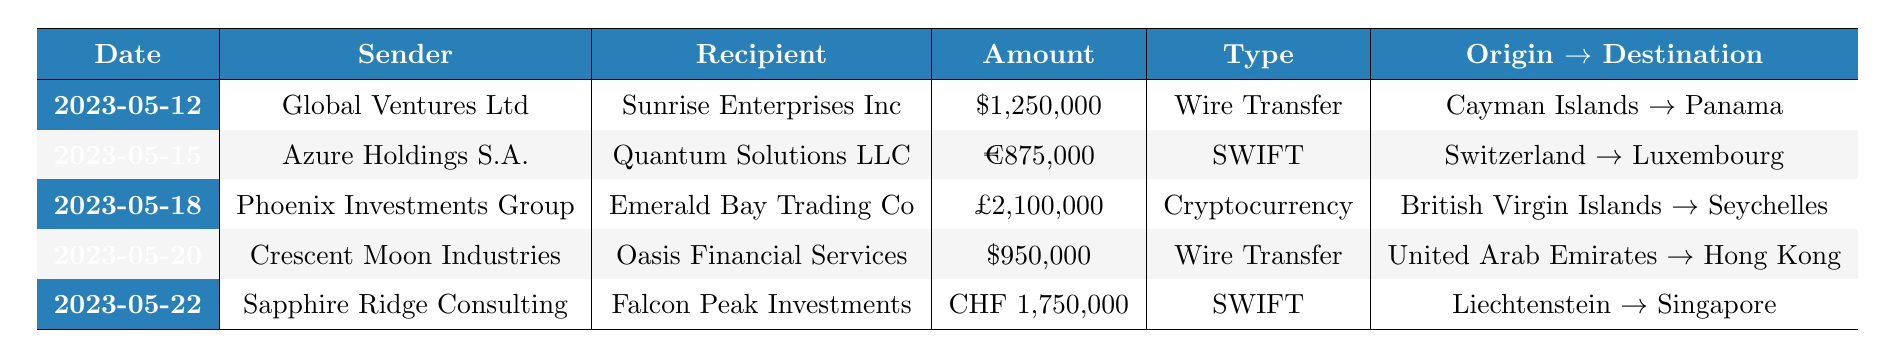What is the total amount of all financial transactions listed in the table? To find the total amount, we need to add together all the transaction amounts: 1,250,000 USD + 875,000 EUR + 2,100,000 GBP + 950,000 USD + 1,750,000 CHF. Each amount is in a different currency, but the question does not require conversion—just a sum of presented values. Therefore, the total amount is the sum of these values as 1,250,000 + 875,000 + 2,100,000 + 950,000 + 1,750,000. The final total is 7,925,000 (not considered in a single currency).
Answer: 7,925,000 Which sender initiated the largest transaction? Looking through the transaction amounts, the largest value is 2,100,000 GBP, which was sent by Phoenix Investments Group. We check each transaction amount against others to confirm this. The maximum amount clearly stands out from the rest.
Answer: Phoenix Investments Group Was there any transaction involving the United States? Examining the table, we see that there are transactions associated with currencies from USD and also a sender (Crescent Moon Industries) and recipient (Oasis Financial Services) linked to the United Arab Emirates and Hong Kong but not directly to the United States. Therefore, the answer is no.
Answer: No How many transactions were conducted using SWIFT? The table shows two transactions that have the transaction type labeled as SWIFT: one from Azure Holdings S.A. to Quantum Solutions LLC and another from Sapphire Ridge Consulting to Falcon Peak Investments. We count these two to find the total.
Answer: 2 Which transaction used cryptocurrency and what was the amount? The currency type of cryptocurrency is utilized in the transaction from Phoenix Investments Group to Emerald Bay Trading Co, with an amount of 2,100,000 GBP specified. We check the type for each transaction; this is the only one identified as cryptocurrency.
Answer: 2,100,000 GBP What is the currency of the smallest transaction in the table? We compare the amounts of each transaction and find the smallest amount is 875,000 EUR from Azure Holdings S.A. to Quantum Solutions LLC. We keep careful track of each transaction amount and their respective currencies. The smallest amount clearly indicates its currency as EUR.
Answer: EUR Which country of origin has the highest number of transactions? Observing each transaction's country of origin, we have Cayman Islands, Switzerland, British Virgin Islands, United Arab Emirates, and Liechtenstein. Each country has only one transaction, meaning there is a tie. Therefore, we conclude there’s no single country with the highest number of transactions.
Answer: No single country dominates; it's a tie 